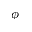<formula> <loc_0><loc_0><loc_500><loc_500>\phi</formula> 